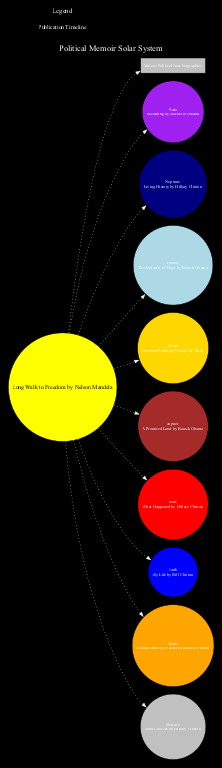What is the memoir associated with the Sun? The Sun in the diagram is labeled with "Long Walk to Freedom by Nelson Mandela." Thus, the memoir associated with the Sun is this title.
Answer: Long Walk to Freedom by Nelson Mandela Which planet is associated with the memoir "What Happened"? The memoir "What Happened" is associated with Mars in the diagram, which directly leads to this conclusion.
Answer: Mars How many planets are labeled in the diagram? The diagram labels nine planets: Mercury, Venus, Earth, Mars, Jupiter, Saturn, Uranus, Neptune, and Pluto. Therefore, counting these gives a total of nine planets.
Answer: Nine What color is the node representing Jupiter? By observing the diagram, the planet Jupiter is colored brown. This identity is clear from its specific label and color coding given in the diagram.
Answer: Brown Compare the memorials of Mars and Earth: which memoir was published more recently? Mars has "What Happened" by Hillary Clinton and Earth has "My Life" by Bill Clinton. Since "What Happened" was published more recently than "My Life," we conclude that Mars has the more recent memoir.
Answer: Mars What does the Asteroid Belt represent in this diagram? The Asteroid Belt is labeled as "Various Political Autobiographies," indicating that it encompasses a collection of different political memoirs rather than a single memoir.
Answer: Various Political Autobiographies What is the significance of the Orbit Paths in the diagram? The Orbit Paths are labeled as "Publication Timeline," which suggests that they represent the temporal aspect of when the political memoirs were published, providing context to the arrangement of the planets.
Answer: Publication Timeline Which political figure is associated with Neptune? In the diagram, Neptune is associated with "Living History by Hillary Clinton," making this the relevant political figure linked with the planet.
Answer: Hillary Clinton How many edges connect to the Sun node? The Sun node connects to ten other nodes: the nine planets plus the Asteroid Belt. Therefore, there are ten edges leading away from the Sun in the diagram.
Answer: Ten 